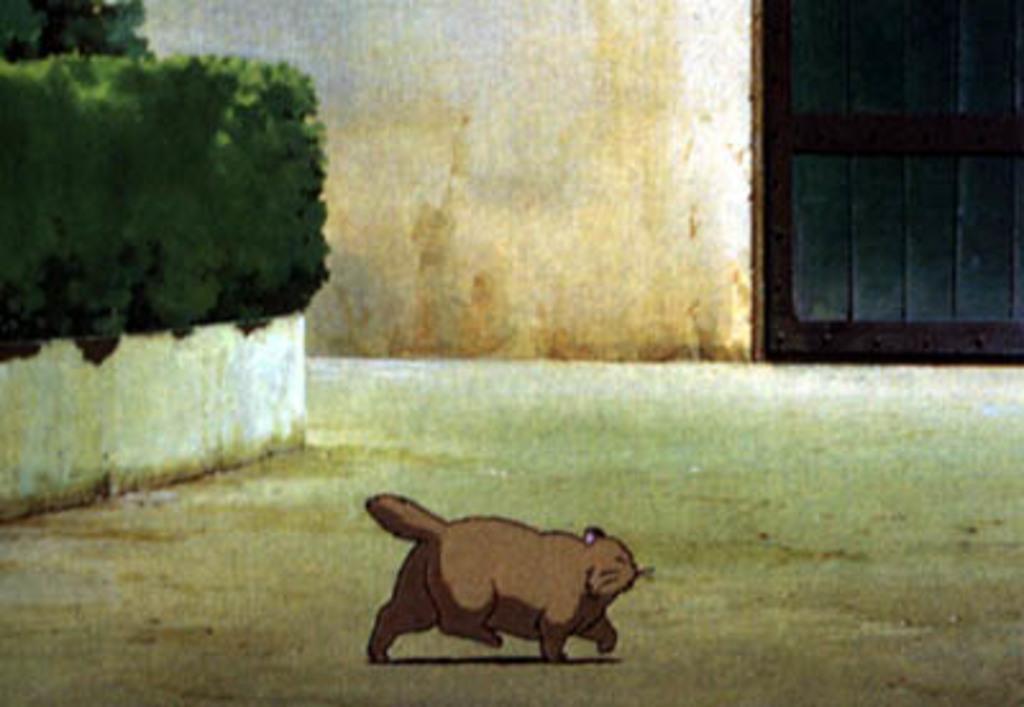Can you describe this image briefly? In this image, we can see a cartoon and in the background, there is a door, wall and we can see some plants. At the bottom, there is ground. 